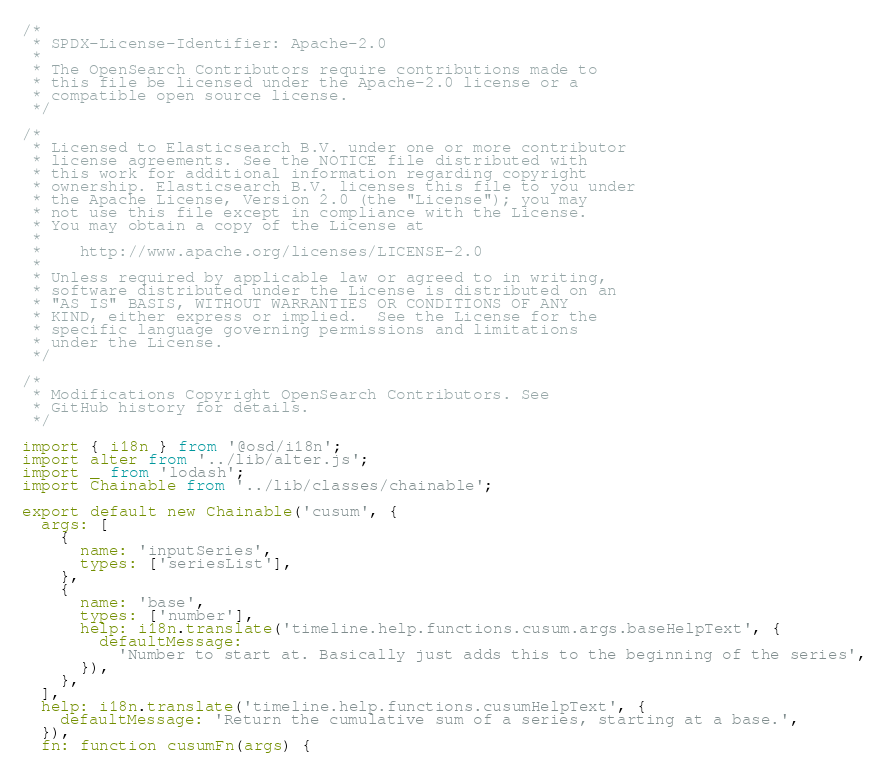Convert code to text. <code><loc_0><loc_0><loc_500><loc_500><_JavaScript_>/*
 * SPDX-License-Identifier: Apache-2.0
 *
 * The OpenSearch Contributors require contributions made to
 * this file be licensed under the Apache-2.0 license or a
 * compatible open source license.
 */

/*
 * Licensed to Elasticsearch B.V. under one or more contributor
 * license agreements. See the NOTICE file distributed with
 * this work for additional information regarding copyright
 * ownership. Elasticsearch B.V. licenses this file to you under
 * the Apache License, Version 2.0 (the "License"); you may
 * not use this file except in compliance with the License.
 * You may obtain a copy of the License at
 *
 *    http://www.apache.org/licenses/LICENSE-2.0
 *
 * Unless required by applicable law or agreed to in writing,
 * software distributed under the License is distributed on an
 * "AS IS" BASIS, WITHOUT WARRANTIES OR CONDITIONS OF ANY
 * KIND, either express or implied.  See the License for the
 * specific language governing permissions and limitations
 * under the License.
 */

/*
 * Modifications Copyright OpenSearch Contributors. See
 * GitHub history for details.
 */

import { i18n } from '@osd/i18n';
import alter from '../lib/alter.js';
import _ from 'lodash';
import Chainable from '../lib/classes/chainable';

export default new Chainable('cusum', {
  args: [
    {
      name: 'inputSeries',
      types: ['seriesList'],
    },
    {
      name: 'base',
      types: ['number'],
      help: i18n.translate('timeline.help.functions.cusum.args.baseHelpText', {
        defaultMessage:
          'Number to start at. Basically just adds this to the beginning of the series',
      }),
    },
  ],
  help: i18n.translate('timeline.help.functions.cusumHelpText', {
    defaultMessage: 'Return the cumulative sum of a series, starting at a base.',
  }),
  fn: function cusumFn(args) {</code> 